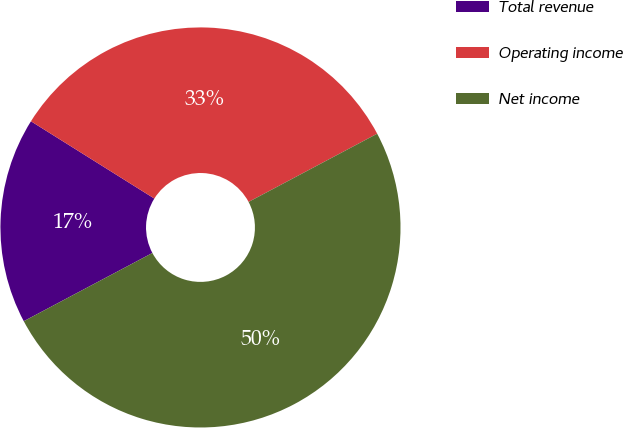Convert chart to OTSL. <chart><loc_0><loc_0><loc_500><loc_500><pie_chart><fcel>Total revenue<fcel>Operating income<fcel>Net income<nl><fcel>16.67%<fcel>33.33%<fcel>50.0%<nl></chart> 